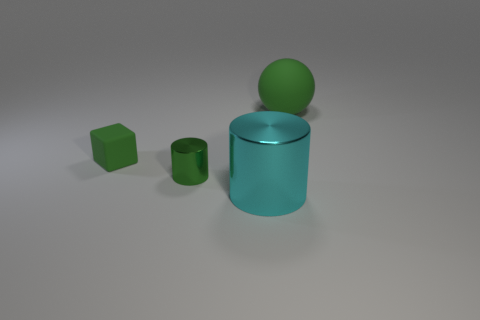Subtract all blue cylinders. Subtract all green cubes. How many cylinders are left? 2 Add 4 gray metallic objects. How many objects exist? 8 Subtract all balls. How many objects are left? 3 Add 4 big brown shiny spheres. How many big brown shiny spheres exist? 4 Subtract 0 purple blocks. How many objects are left? 4 Subtract all small blocks. Subtract all blue metallic balls. How many objects are left? 3 Add 4 large green rubber spheres. How many large green rubber spheres are left? 5 